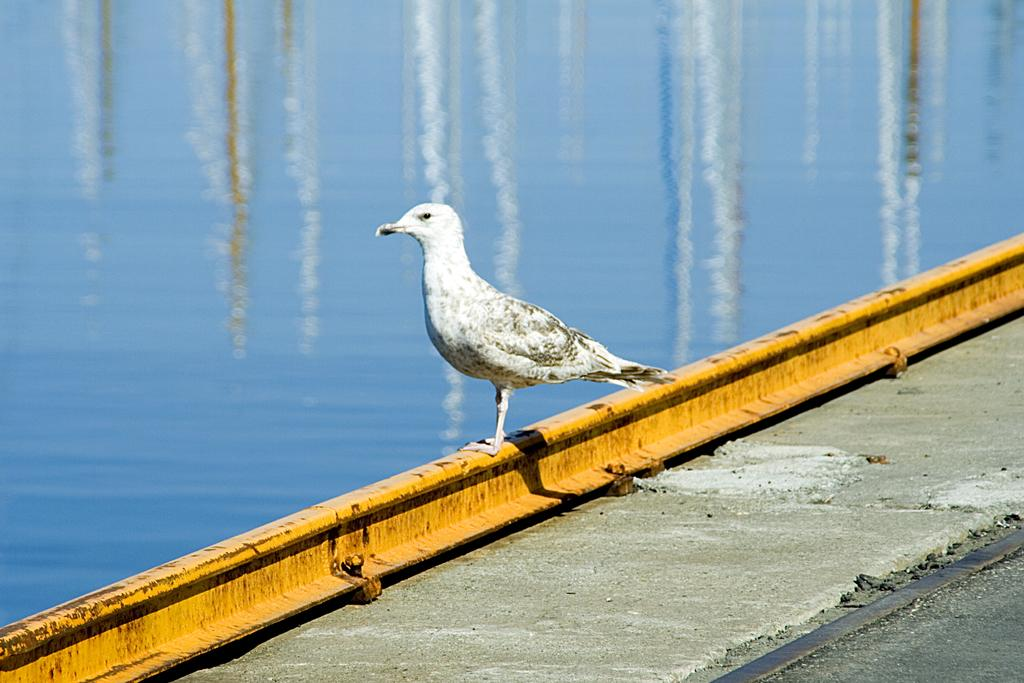What is located at the top of the image? There is a water body at the top of the image. What can be seen in the middle of the image? There is a bird in the middle of the image. What is the color of the bird? The bird is white in color. What is present in the foreground of the image? There is a platform in the foreground of the image. Where can you find the fuel for the bird's flight in the image? There is no fuel present in the image, as birds do not require fuel for flight. What type of ticket is the bird holding in the image? There is no ticket present in the image, as birds do not use tickets. 